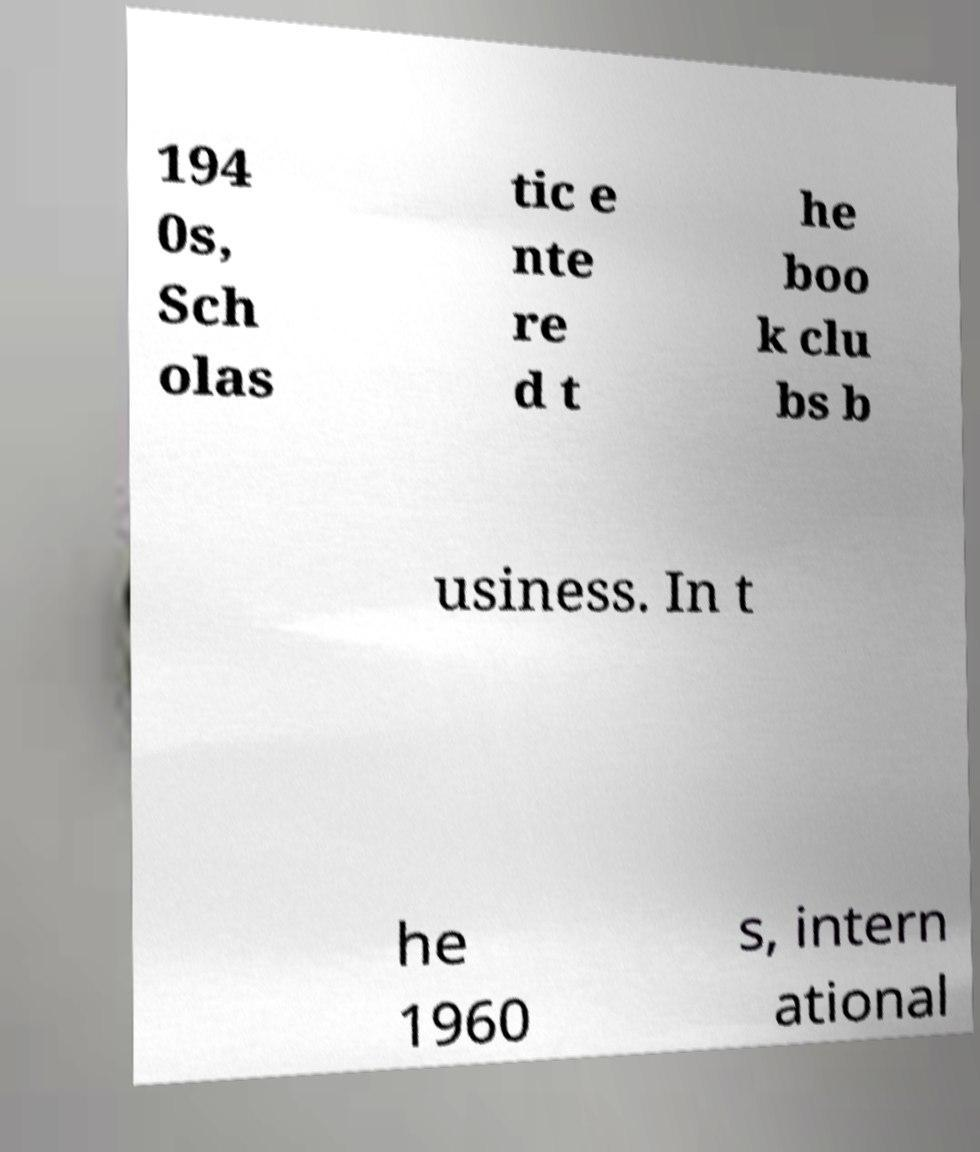What messages or text are displayed in this image? I need them in a readable, typed format. 194 0s, Sch olas tic e nte re d t he boo k clu bs b usiness. In t he 1960 s, intern ational 